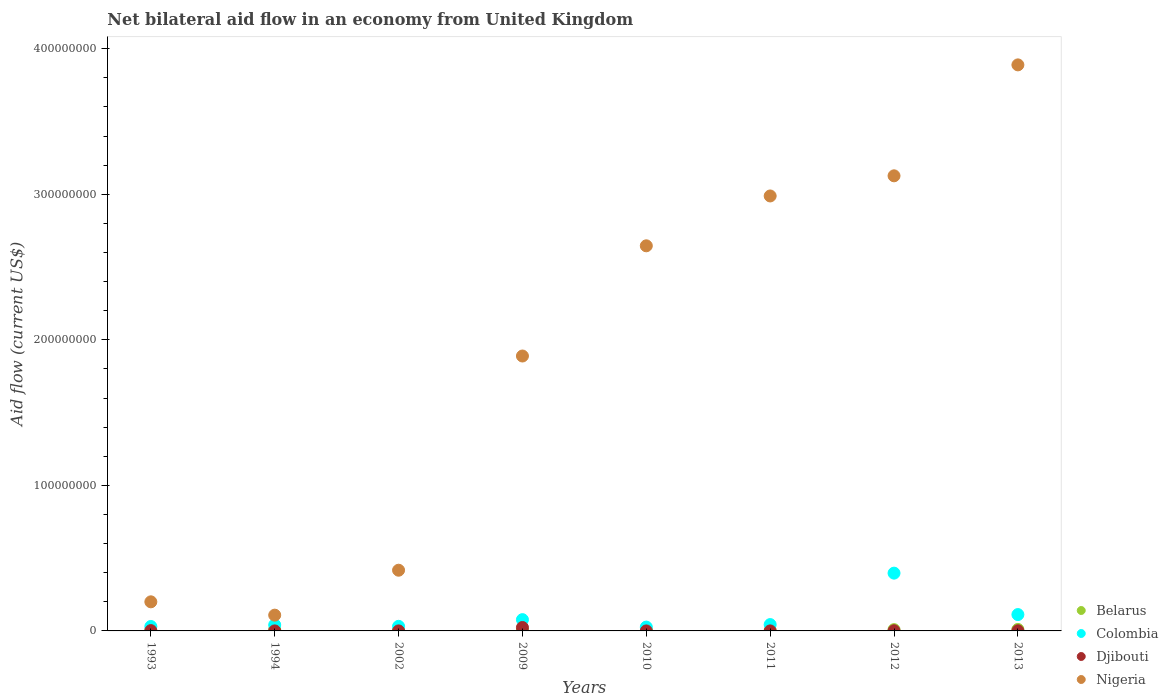How many different coloured dotlines are there?
Your response must be concise. 4. What is the net bilateral aid flow in Belarus in 1993?
Provide a succinct answer. 1.70e+05. Across all years, what is the maximum net bilateral aid flow in Djibouti?
Your response must be concise. 2.35e+06. Across all years, what is the minimum net bilateral aid flow in Nigeria?
Make the answer very short. 1.08e+07. In which year was the net bilateral aid flow in Djibouti maximum?
Offer a very short reply. 2009. In which year was the net bilateral aid flow in Belarus minimum?
Your answer should be compact. 2002. What is the total net bilateral aid flow in Belarus in the graph?
Your answer should be very brief. 4.17e+06. What is the difference between the net bilateral aid flow in Belarus in 1994 and that in 2002?
Your answer should be compact. 8.20e+05. What is the difference between the net bilateral aid flow in Djibouti in 2002 and the net bilateral aid flow in Nigeria in 2013?
Make the answer very short. -3.89e+08. What is the average net bilateral aid flow in Colombia per year?
Provide a succinct answer. 9.50e+06. In the year 1994, what is the difference between the net bilateral aid flow in Djibouti and net bilateral aid flow in Belarus?
Your answer should be very brief. -8.90e+05. What is the ratio of the net bilateral aid flow in Nigeria in 1993 to that in 2013?
Offer a terse response. 0.05. Is the net bilateral aid flow in Colombia in 2010 less than that in 2012?
Offer a terse response. Yes. What is the difference between the highest and the second highest net bilateral aid flow in Djibouti?
Provide a succinct answer. 2.14e+06. What is the difference between the highest and the lowest net bilateral aid flow in Belarus?
Your answer should be very brief. 9.30e+05. Is the sum of the net bilateral aid flow in Nigeria in 1993 and 1994 greater than the maximum net bilateral aid flow in Djibouti across all years?
Provide a succinct answer. Yes. Is it the case that in every year, the sum of the net bilateral aid flow in Colombia and net bilateral aid flow in Nigeria  is greater than the net bilateral aid flow in Djibouti?
Your answer should be very brief. Yes. Does the net bilateral aid flow in Djibouti monotonically increase over the years?
Provide a succinct answer. No. Is the net bilateral aid flow in Djibouti strictly greater than the net bilateral aid flow in Colombia over the years?
Offer a terse response. No. How many years are there in the graph?
Offer a terse response. 8. What is the difference between two consecutive major ticks on the Y-axis?
Give a very brief answer. 1.00e+08. Are the values on the major ticks of Y-axis written in scientific E-notation?
Ensure brevity in your answer.  No. Does the graph contain grids?
Your response must be concise. No. Where does the legend appear in the graph?
Give a very brief answer. Bottom right. How many legend labels are there?
Provide a succinct answer. 4. What is the title of the graph?
Offer a very short reply. Net bilateral aid flow in an economy from United Kingdom. What is the label or title of the X-axis?
Give a very brief answer. Years. What is the label or title of the Y-axis?
Your answer should be compact. Aid flow (current US$). What is the Aid flow (current US$) of Belarus in 1993?
Keep it short and to the point. 1.70e+05. What is the Aid flow (current US$) in Colombia in 1993?
Make the answer very short. 3.04e+06. What is the Aid flow (current US$) of Nigeria in 1993?
Keep it short and to the point. 2.00e+07. What is the Aid flow (current US$) of Belarus in 1994?
Give a very brief answer. 9.10e+05. What is the Aid flow (current US$) in Colombia in 1994?
Ensure brevity in your answer.  4.12e+06. What is the Aid flow (current US$) of Nigeria in 1994?
Offer a terse response. 1.08e+07. What is the Aid flow (current US$) in Belarus in 2002?
Your answer should be compact. 9.00e+04. What is the Aid flow (current US$) in Colombia in 2002?
Your answer should be compact. 3.15e+06. What is the Aid flow (current US$) of Nigeria in 2002?
Keep it short and to the point. 4.17e+07. What is the Aid flow (current US$) in Belarus in 2009?
Your response must be concise. 6.10e+05. What is the Aid flow (current US$) in Colombia in 2009?
Your answer should be compact. 7.75e+06. What is the Aid flow (current US$) of Djibouti in 2009?
Give a very brief answer. 2.35e+06. What is the Aid flow (current US$) of Nigeria in 2009?
Make the answer very short. 1.89e+08. What is the Aid flow (current US$) of Colombia in 2010?
Provide a short and direct response. 2.64e+06. What is the Aid flow (current US$) of Djibouti in 2010?
Ensure brevity in your answer.  10000. What is the Aid flow (current US$) of Nigeria in 2010?
Keep it short and to the point. 2.65e+08. What is the Aid flow (current US$) of Belarus in 2011?
Make the answer very short. 1.20e+05. What is the Aid flow (current US$) of Colombia in 2011?
Ensure brevity in your answer.  4.36e+06. What is the Aid flow (current US$) of Djibouti in 2011?
Make the answer very short. 2.00e+04. What is the Aid flow (current US$) of Nigeria in 2011?
Give a very brief answer. 2.99e+08. What is the Aid flow (current US$) of Belarus in 2012?
Your answer should be compact. 8.80e+05. What is the Aid flow (current US$) of Colombia in 2012?
Ensure brevity in your answer.  3.97e+07. What is the Aid flow (current US$) of Nigeria in 2012?
Give a very brief answer. 3.13e+08. What is the Aid flow (current US$) in Belarus in 2013?
Provide a short and direct response. 1.02e+06. What is the Aid flow (current US$) of Colombia in 2013?
Provide a succinct answer. 1.12e+07. What is the Aid flow (current US$) of Nigeria in 2013?
Make the answer very short. 3.89e+08. Across all years, what is the maximum Aid flow (current US$) of Belarus?
Give a very brief answer. 1.02e+06. Across all years, what is the maximum Aid flow (current US$) of Colombia?
Ensure brevity in your answer.  3.97e+07. Across all years, what is the maximum Aid flow (current US$) of Djibouti?
Keep it short and to the point. 2.35e+06. Across all years, what is the maximum Aid flow (current US$) of Nigeria?
Make the answer very short. 3.89e+08. Across all years, what is the minimum Aid flow (current US$) in Colombia?
Ensure brevity in your answer.  2.64e+06. Across all years, what is the minimum Aid flow (current US$) of Nigeria?
Your answer should be compact. 1.08e+07. What is the total Aid flow (current US$) of Belarus in the graph?
Offer a terse response. 4.17e+06. What is the total Aid flow (current US$) of Colombia in the graph?
Provide a succinct answer. 7.60e+07. What is the total Aid flow (current US$) in Djibouti in the graph?
Provide a succinct answer. 2.84e+06. What is the total Aid flow (current US$) of Nigeria in the graph?
Make the answer very short. 1.53e+09. What is the difference between the Aid flow (current US$) of Belarus in 1993 and that in 1994?
Your answer should be very brief. -7.40e+05. What is the difference between the Aid flow (current US$) in Colombia in 1993 and that in 1994?
Offer a very short reply. -1.08e+06. What is the difference between the Aid flow (current US$) in Djibouti in 1993 and that in 1994?
Your response must be concise. 1.90e+05. What is the difference between the Aid flow (current US$) of Nigeria in 1993 and that in 1994?
Offer a terse response. 9.15e+06. What is the difference between the Aid flow (current US$) of Belarus in 1993 and that in 2002?
Make the answer very short. 8.00e+04. What is the difference between the Aid flow (current US$) of Colombia in 1993 and that in 2002?
Provide a succinct answer. -1.10e+05. What is the difference between the Aid flow (current US$) in Nigeria in 1993 and that in 2002?
Provide a short and direct response. -2.17e+07. What is the difference between the Aid flow (current US$) of Belarus in 1993 and that in 2009?
Ensure brevity in your answer.  -4.40e+05. What is the difference between the Aid flow (current US$) of Colombia in 1993 and that in 2009?
Your answer should be compact. -4.71e+06. What is the difference between the Aid flow (current US$) of Djibouti in 1993 and that in 2009?
Make the answer very short. -2.14e+06. What is the difference between the Aid flow (current US$) of Nigeria in 1993 and that in 2009?
Your answer should be compact. -1.69e+08. What is the difference between the Aid flow (current US$) in Colombia in 1993 and that in 2010?
Provide a short and direct response. 4.00e+05. What is the difference between the Aid flow (current US$) in Djibouti in 1993 and that in 2010?
Keep it short and to the point. 2.00e+05. What is the difference between the Aid flow (current US$) in Nigeria in 1993 and that in 2010?
Provide a short and direct response. -2.45e+08. What is the difference between the Aid flow (current US$) in Belarus in 1993 and that in 2011?
Give a very brief answer. 5.00e+04. What is the difference between the Aid flow (current US$) of Colombia in 1993 and that in 2011?
Your answer should be compact. -1.32e+06. What is the difference between the Aid flow (current US$) in Nigeria in 1993 and that in 2011?
Keep it short and to the point. -2.79e+08. What is the difference between the Aid flow (current US$) in Belarus in 1993 and that in 2012?
Give a very brief answer. -7.10e+05. What is the difference between the Aid flow (current US$) in Colombia in 1993 and that in 2012?
Your answer should be very brief. -3.67e+07. What is the difference between the Aid flow (current US$) in Nigeria in 1993 and that in 2012?
Your answer should be compact. -2.93e+08. What is the difference between the Aid flow (current US$) of Belarus in 1993 and that in 2013?
Your answer should be compact. -8.50e+05. What is the difference between the Aid flow (current US$) of Colombia in 1993 and that in 2013?
Provide a short and direct response. -8.20e+06. What is the difference between the Aid flow (current US$) of Nigeria in 1993 and that in 2013?
Offer a terse response. -3.69e+08. What is the difference between the Aid flow (current US$) of Belarus in 1994 and that in 2002?
Keep it short and to the point. 8.20e+05. What is the difference between the Aid flow (current US$) of Colombia in 1994 and that in 2002?
Provide a short and direct response. 9.70e+05. What is the difference between the Aid flow (current US$) in Nigeria in 1994 and that in 2002?
Keep it short and to the point. -3.09e+07. What is the difference between the Aid flow (current US$) in Belarus in 1994 and that in 2009?
Your answer should be very brief. 3.00e+05. What is the difference between the Aid flow (current US$) in Colombia in 1994 and that in 2009?
Offer a terse response. -3.63e+06. What is the difference between the Aid flow (current US$) of Djibouti in 1994 and that in 2009?
Give a very brief answer. -2.33e+06. What is the difference between the Aid flow (current US$) in Nigeria in 1994 and that in 2009?
Keep it short and to the point. -1.78e+08. What is the difference between the Aid flow (current US$) of Belarus in 1994 and that in 2010?
Your response must be concise. 5.40e+05. What is the difference between the Aid flow (current US$) of Colombia in 1994 and that in 2010?
Your answer should be very brief. 1.48e+06. What is the difference between the Aid flow (current US$) of Djibouti in 1994 and that in 2010?
Your answer should be compact. 10000. What is the difference between the Aid flow (current US$) in Nigeria in 1994 and that in 2010?
Your response must be concise. -2.54e+08. What is the difference between the Aid flow (current US$) in Belarus in 1994 and that in 2011?
Make the answer very short. 7.90e+05. What is the difference between the Aid flow (current US$) of Nigeria in 1994 and that in 2011?
Offer a terse response. -2.88e+08. What is the difference between the Aid flow (current US$) of Colombia in 1994 and that in 2012?
Ensure brevity in your answer.  -3.56e+07. What is the difference between the Aid flow (current US$) of Djibouti in 1994 and that in 2012?
Offer a terse response. -9.00e+04. What is the difference between the Aid flow (current US$) of Nigeria in 1994 and that in 2012?
Offer a terse response. -3.02e+08. What is the difference between the Aid flow (current US$) of Colombia in 1994 and that in 2013?
Provide a succinct answer. -7.12e+06. What is the difference between the Aid flow (current US$) of Nigeria in 1994 and that in 2013?
Provide a succinct answer. -3.78e+08. What is the difference between the Aid flow (current US$) of Belarus in 2002 and that in 2009?
Provide a short and direct response. -5.20e+05. What is the difference between the Aid flow (current US$) in Colombia in 2002 and that in 2009?
Your answer should be compact. -4.60e+06. What is the difference between the Aid flow (current US$) in Djibouti in 2002 and that in 2009?
Ensure brevity in your answer.  -2.33e+06. What is the difference between the Aid flow (current US$) of Nigeria in 2002 and that in 2009?
Provide a succinct answer. -1.47e+08. What is the difference between the Aid flow (current US$) of Belarus in 2002 and that in 2010?
Give a very brief answer. -2.80e+05. What is the difference between the Aid flow (current US$) of Colombia in 2002 and that in 2010?
Make the answer very short. 5.10e+05. What is the difference between the Aid flow (current US$) of Nigeria in 2002 and that in 2010?
Offer a very short reply. -2.23e+08. What is the difference between the Aid flow (current US$) in Belarus in 2002 and that in 2011?
Give a very brief answer. -3.00e+04. What is the difference between the Aid flow (current US$) of Colombia in 2002 and that in 2011?
Your answer should be very brief. -1.21e+06. What is the difference between the Aid flow (current US$) of Djibouti in 2002 and that in 2011?
Your response must be concise. 0. What is the difference between the Aid flow (current US$) in Nigeria in 2002 and that in 2011?
Ensure brevity in your answer.  -2.57e+08. What is the difference between the Aid flow (current US$) in Belarus in 2002 and that in 2012?
Provide a short and direct response. -7.90e+05. What is the difference between the Aid flow (current US$) in Colombia in 2002 and that in 2012?
Your answer should be very brief. -3.66e+07. What is the difference between the Aid flow (current US$) of Nigeria in 2002 and that in 2012?
Your answer should be compact. -2.71e+08. What is the difference between the Aid flow (current US$) in Belarus in 2002 and that in 2013?
Your answer should be compact. -9.30e+05. What is the difference between the Aid flow (current US$) of Colombia in 2002 and that in 2013?
Your answer should be compact. -8.09e+06. What is the difference between the Aid flow (current US$) of Djibouti in 2002 and that in 2013?
Keep it short and to the point. -8.00e+04. What is the difference between the Aid flow (current US$) in Nigeria in 2002 and that in 2013?
Make the answer very short. -3.47e+08. What is the difference between the Aid flow (current US$) in Colombia in 2009 and that in 2010?
Give a very brief answer. 5.11e+06. What is the difference between the Aid flow (current US$) of Djibouti in 2009 and that in 2010?
Make the answer very short. 2.34e+06. What is the difference between the Aid flow (current US$) in Nigeria in 2009 and that in 2010?
Offer a terse response. -7.57e+07. What is the difference between the Aid flow (current US$) in Belarus in 2009 and that in 2011?
Your answer should be compact. 4.90e+05. What is the difference between the Aid flow (current US$) of Colombia in 2009 and that in 2011?
Provide a short and direct response. 3.39e+06. What is the difference between the Aid flow (current US$) in Djibouti in 2009 and that in 2011?
Your response must be concise. 2.33e+06. What is the difference between the Aid flow (current US$) in Nigeria in 2009 and that in 2011?
Provide a short and direct response. -1.10e+08. What is the difference between the Aid flow (current US$) of Belarus in 2009 and that in 2012?
Your answer should be compact. -2.70e+05. What is the difference between the Aid flow (current US$) of Colombia in 2009 and that in 2012?
Offer a very short reply. -3.20e+07. What is the difference between the Aid flow (current US$) of Djibouti in 2009 and that in 2012?
Keep it short and to the point. 2.24e+06. What is the difference between the Aid flow (current US$) in Nigeria in 2009 and that in 2012?
Offer a terse response. -1.24e+08. What is the difference between the Aid flow (current US$) in Belarus in 2009 and that in 2013?
Give a very brief answer. -4.10e+05. What is the difference between the Aid flow (current US$) of Colombia in 2009 and that in 2013?
Keep it short and to the point. -3.49e+06. What is the difference between the Aid flow (current US$) in Djibouti in 2009 and that in 2013?
Keep it short and to the point. 2.25e+06. What is the difference between the Aid flow (current US$) in Nigeria in 2009 and that in 2013?
Offer a terse response. -2.00e+08. What is the difference between the Aid flow (current US$) in Colombia in 2010 and that in 2011?
Your answer should be very brief. -1.72e+06. What is the difference between the Aid flow (current US$) of Nigeria in 2010 and that in 2011?
Your answer should be compact. -3.42e+07. What is the difference between the Aid flow (current US$) in Belarus in 2010 and that in 2012?
Offer a terse response. -5.10e+05. What is the difference between the Aid flow (current US$) of Colombia in 2010 and that in 2012?
Keep it short and to the point. -3.71e+07. What is the difference between the Aid flow (current US$) in Djibouti in 2010 and that in 2012?
Give a very brief answer. -1.00e+05. What is the difference between the Aid flow (current US$) in Nigeria in 2010 and that in 2012?
Your answer should be compact. -4.81e+07. What is the difference between the Aid flow (current US$) of Belarus in 2010 and that in 2013?
Offer a terse response. -6.50e+05. What is the difference between the Aid flow (current US$) of Colombia in 2010 and that in 2013?
Make the answer very short. -8.60e+06. What is the difference between the Aid flow (current US$) of Nigeria in 2010 and that in 2013?
Provide a short and direct response. -1.24e+08. What is the difference between the Aid flow (current US$) in Belarus in 2011 and that in 2012?
Provide a succinct answer. -7.60e+05. What is the difference between the Aid flow (current US$) of Colombia in 2011 and that in 2012?
Ensure brevity in your answer.  -3.53e+07. What is the difference between the Aid flow (current US$) in Nigeria in 2011 and that in 2012?
Your response must be concise. -1.38e+07. What is the difference between the Aid flow (current US$) in Belarus in 2011 and that in 2013?
Keep it short and to the point. -9.00e+05. What is the difference between the Aid flow (current US$) of Colombia in 2011 and that in 2013?
Ensure brevity in your answer.  -6.88e+06. What is the difference between the Aid flow (current US$) of Nigeria in 2011 and that in 2013?
Your response must be concise. -9.01e+07. What is the difference between the Aid flow (current US$) of Belarus in 2012 and that in 2013?
Provide a succinct answer. -1.40e+05. What is the difference between the Aid flow (current US$) of Colombia in 2012 and that in 2013?
Offer a terse response. 2.85e+07. What is the difference between the Aid flow (current US$) of Djibouti in 2012 and that in 2013?
Your answer should be compact. 10000. What is the difference between the Aid flow (current US$) in Nigeria in 2012 and that in 2013?
Ensure brevity in your answer.  -7.62e+07. What is the difference between the Aid flow (current US$) in Belarus in 1993 and the Aid flow (current US$) in Colombia in 1994?
Your answer should be very brief. -3.95e+06. What is the difference between the Aid flow (current US$) in Belarus in 1993 and the Aid flow (current US$) in Nigeria in 1994?
Ensure brevity in your answer.  -1.07e+07. What is the difference between the Aid flow (current US$) of Colombia in 1993 and the Aid flow (current US$) of Djibouti in 1994?
Provide a succinct answer. 3.02e+06. What is the difference between the Aid flow (current US$) of Colombia in 1993 and the Aid flow (current US$) of Nigeria in 1994?
Make the answer very short. -7.80e+06. What is the difference between the Aid flow (current US$) in Djibouti in 1993 and the Aid flow (current US$) in Nigeria in 1994?
Keep it short and to the point. -1.06e+07. What is the difference between the Aid flow (current US$) in Belarus in 1993 and the Aid flow (current US$) in Colombia in 2002?
Your answer should be compact. -2.98e+06. What is the difference between the Aid flow (current US$) in Belarus in 1993 and the Aid flow (current US$) in Djibouti in 2002?
Make the answer very short. 1.50e+05. What is the difference between the Aid flow (current US$) in Belarus in 1993 and the Aid flow (current US$) in Nigeria in 2002?
Offer a terse response. -4.15e+07. What is the difference between the Aid flow (current US$) of Colombia in 1993 and the Aid flow (current US$) of Djibouti in 2002?
Offer a very short reply. 3.02e+06. What is the difference between the Aid flow (current US$) in Colombia in 1993 and the Aid flow (current US$) in Nigeria in 2002?
Your response must be concise. -3.87e+07. What is the difference between the Aid flow (current US$) in Djibouti in 1993 and the Aid flow (current US$) in Nigeria in 2002?
Keep it short and to the point. -4.15e+07. What is the difference between the Aid flow (current US$) in Belarus in 1993 and the Aid flow (current US$) in Colombia in 2009?
Offer a terse response. -7.58e+06. What is the difference between the Aid flow (current US$) in Belarus in 1993 and the Aid flow (current US$) in Djibouti in 2009?
Your answer should be compact. -2.18e+06. What is the difference between the Aid flow (current US$) of Belarus in 1993 and the Aid flow (current US$) of Nigeria in 2009?
Your answer should be compact. -1.89e+08. What is the difference between the Aid flow (current US$) of Colombia in 1993 and the Aid flow (current US$) of Djibouti in 2009?
Make the answer very short. 6.90e+05. What is the difference between the Aid flow (current US$) of Colombia in 1993 and the Aid flow (current US$) of Nigeria in 2009?
Your answer should be compact. -1.86e+08. What is the difference between the Aid flow (current US$) in Djibouti in 1993 and the Aid flow (current US$) in Nigeria in 2009?
Provide a succinct answer. -1.89e+08. What is the difference between the Aid flow (current US$) in Belarus in 1993 and the Aid flow (current US$) in Colombia in 2010?
Ensure brevity in your answer.  -2.47e+06. What is the difference between the Aid flow (current US$) of Belarus in 1993 and the Aid flow (current US$) of Djibouti in 2010?
Keep it short and to the point. 1.60e+05. What is the difference between the Aid flow (current US$) in Belarus in 1993 and the Aid flow (current US$) in Nigeria in 2010?
Your response must be concise. -2.64e+08. What is the difference between the Aid flow (current US$) in Colombia in 1993 and the Aid flow (current US$) in Djibouti in 2010?
Your response must be concise. 3.03e+06. What is the difference between the Aid flow (current US$) in Colombia in 1993 and the Aid flow (current US$) in Nigeria in 2010?
Give a very brief answer. -2.62e+08. What is the difference between the Aid flow (current US$) of Djibouti in 1993 and the Aid flow (current US$) of Nigeria in 2010?
Provide a succinct answer. -2.64e+08. What is the difference between the Aid flow (current US$) of Belarus in 1993 and the Aid flow (current US$) of Colombia in 2011?
Ensure brevity in your answer.  -4.19e+06. What is the difference between the Aid flow (current US$) in Belarus in 1993 and the Aid flow (current US$) in Nigeria in 2011?
Your answer should be very brief. -2.99e+08. What is the difference between the Aid flow (current US$) in Colombia in 1993 and the Aid flow (current US$) in Djibouti in 2011?
Provide a succinct answer. 3.02e+06. What is the difference between the Aid flow (current US$) in Colombia in 1993 and the Aid flow (current US$) in Nigeria in 2011?
Your answer should be very brief. -2.96e+08. What is the difference between the Aid flow (current US$) of Djibouti in 1993 and the Aid flow (current US$) of Nigeria in 2011?
Your answer should be very brief. -2.99e+08. What is the difference between the Aid flow (current US$) of Belarus in 1993 and the Aid flow (current US$) of Colombia in 2012?
Make the answer very short. -3.95e+07. What is the difference between the Aid flow (current US$) of Belarus in 1993 and the Aid flow (current US$) of Nigeria in 2012?
Provide a succinct answer. -3.13e+08. What is the difference between the Aid flow (current US$) of Colombia in 1993 and the Aid flow (current US$) of Djibouti in 2012?
Make the answer very short. 2.93e+06. What is the difference between the Aid flow (current US$) in Colombia in 1993 and the Aid flow (current US$) in Nigeria in 2012?
Offer a terse response. -3.10e+08. What is the difference between the Aid flow (current US$) in Djibouti in 1993 and the Aid flow (current US$) in Nigeria in 2012?
Give a very brief answer. -3.12e+08. What is the difference between the Aid flow (current US$) in Belarus in 1993 and the Aid flow (current US$) in Colombia in 2013?
Offer a very short reply. -1.11e+07. What is the difference between the Aid flow (current US$) of Belarus in 1993 and the Aid flow (current US$) of Nigeria in 2013?
Your answer should be compact. -3.89e+08. What is the difference between the Aid flow (current US$) in Colombia in 1993 and the Aid flow (current US$) in Djibouti in 2013?
Keep it short and to the point. 2.94e+06. What is the difference between the Aid flow (current US$) in Colombia in 1993 and the Aid flow (current US$) in Nigeria in 2013?
Make the answer very short. -3.86e+08. What is the difference between the Aid flow (current US$) in Djibouti in 1993 and the Aid flow (current US$) in Nigeria in 2013?
Keep it short and to the point. -3.89e+08. What is the difference between the Aid flow (current US$) in Belarus in 1994 and the Aid flow (current US$) in Colombia in 2002?
Keep it short and to the point. -2.24e+06. What is the difference between the Aid flow (current US$) of Belarus in 1994 and the Aid flow (current US$) of Djibouti in 2002?
Provide a short and direct response. 8.90e+05. What is the difference between the Aid flow (current US$) in Belarus in 1994 and the Aid flow (current US$) in Nigeria in 2002?
Keep it short and to the point. -4.08e+07. What is the difference between the Aid flow (current US$) of Colombia in 1994 and the Aid flow (current US$) of Djibouti in 2002?
Your response must be concise. 4.10e+06. What is the difference between the Aid flow (current US$) in Colombia in 1994 and the Aid flow (current US$) in Nigeria in 2002?
Make the answer very short. -3.76e+07. What is the difference between the Aid flow (current US$) in Djibouti in 1994 and the Aid flow (current US$) in Nigeria in 2002?
Provide a succinct answer. -4.17e+07. What is the difference between the Aid flow (current US$) in Belarus in 1994 and the Aid flow (current US$) in Colombia in 2009?
Your answer should be compact. -6.84e+06. What is the difference between the Aid flow (current US$) in Belarus in 1994 and the Aid flow (current US$) in Djibouti in 2009?
Your answer should be compact. -1.44e+06. What is the difference between the Aid flow (current US$) in Belarus in 1994 and the Aid flow (current US$) in Nigeria in 2009?
Offer a very short reply. -1.88e+08. What is the difference between the Aid flow (current US$) in Colombia in 1994 and the Aid flow (current US$) in Djibouti in 2009?
Offer a terse response. 1.77e+06. What is the difference between the Aid flow (current US$) in Colombia in 1994 and the Aid flow (current US$) in Nigeria in 2009?
Offer a very short reply. -1.85e+08. What is the difference between the Aid flow (current US$) in Djibouti in 1994 and the Aid flow (current US$) in Nigeria in 2009?
Provide a succinct answer. -1.89e+08. What is the difference between the Aid flow (current US$) in Belarus in 1994 and the Aid flow (current US$) in Colombia in 2010?
Your response must be concise. -1.73e+06. What is the difference between the Aid flow (current US$) in Belarus in 1994 and the Aid flow (current US$) in Djibouti in 2010?
Your response must be concise. 9.00e+05. What is the difference between the Aid flow (current US$) of Belarus in 1994 and the Aid flow (current US$) of Nigeria in 2010?
Provide a succinct answer. -2.64e+08. What is the difference between the Aid flow (current US$) in Colombia in 1994 and the Aid flow (current US$) in Djibouti in 2010?
Your response must be concise. 4.11e+06. What is the difference between the Aid flow (current US$) of Colombia in 1994 and the Aid flow (current US$) of Nigeria in 2010?
Ensure brevity in your answer.  -2.60e+08. What is the difference between the Aid flow (current US$) of Djibouti in 1994 and the Aid flow (current US$) of Nigeria in 2010?
Provide a succinct answer. -2.65e+08. What is the difference between the Aid flow (current US$) of Belarus in 1994 and the Aid flow (current US$) of Colombia in 2011?
Your answer should be very brief. -3.45e+06. What is the difference between the Aid flow (current US$) in Belarus in 1994 and the Aid flow (current US$) in Djibouti in 2011?
Your answer should be very brief. 8.90e+05. What is the difference between the Aid flow (current US$) in Belarus in 1994 and the Aid flow (current US$) in Nigeria in 2011?
Offer a terse response. -2.98e+08. What is the difference between the Aid flow (current US$) of Colombia in 1994 and the Aid flow (current US$) of Djibouti in 2011?
Your answer should be very brief. 4.10e+06. What is the difference between the Aid flow (current US$) of Colombia in 1994 and the Aid flow (current US$) of Nigeria in 2011?
Your answer should be compact. -2.95e+08. What is the difference between the Aid flow (current US$) of Djibouti in 1994 and the Aid flow (current US$) of Nigeria in 2011?
Your response must be concise. -2.99e+08. What is the difference between the Aid flow (current US$) of Belarus in 1994 and the Aid flow (current US$) of Colombia in 2012?
Provide a succinct answer. -3.88e+07. What is the difference between the Aid flow (current US$) of Belarus in 1994 and the Aid flow (current US$) of Nigeria in 2012?
Make the answer very short. -3.12e+08. What is the difference between the Aid flow (current US$) in Colombia in 1994 and the Aid flow (current US$) in Djibouti in 2012?
Offer a very short reply. 4.01e+06. What is the difference between the Aid flow (current US$) in Colombia in 1994 and the Aid flow (current US$) in Nigeria in 2012?
Keep it short and to the point. -3.09e+08. What is the difference between the Aid flow (current US$) in Djibouti in 1994 and the Aid flow (current US$) in Nigeria in 2012?
Make the answer very short. -3.13e+08. What is the difference between the Aid flow (current US$) in Belarus in 1994 and the Aid flow (current US$) in Colombia in 2013?
Give a very brief answer. -1.03e+07. What is the difference between the Aid flow (current US$) in Belarus in 1994 and the Aid flow (current US$) in Djibouti in 2013?
Keep it short and to the point. 8.10e+05. What is the difference between the Aid flow (current US$) in Belarus in 1994 and the Aid flow (current US$) in Nigeria in 2013?
Your answer should be very brief. -3.88e+08. What is the difference between the Aid flow (current US$) in Colombia in 1994 and the Aid flow (current US$) in Djibouti in 2013?
Offer a terse response. 4.02e+06. What is the difference between the Aid flow (current US$) in Colombia in 1994 and the Aid flow (current US$) in Nigeria in 2013?
Your response must be concise. -3.85e+08. What is the difference between the Aid flow (current US$) in Djibouti in 1994 and the Aid flow (current US$) in Nigeria in 2013?
Offer a very short reply. -3.89e+08. What is the difference between the Aid flow (current US$) of Belarus in 2002 and the Aid flow (current US$) of Colombia in 2009?
Ensure brevity in your answer.  -7.66e+06. What is the difference between the Aid flow (current US$) in Belarus in 2002 and the Aid flow (current US$) in Djibouti in 2009?
Offer a terse response. -2.26e+06. What is the difference between the Aid flow (current US$) in Belarus in 2002 and the Aid flow (current US$) in Nigeria in 2009?
Your response must be concise. -1.89e+08. What is the difference between the Aid flow (current US$) of Colombia in 2002 and the Aid flow (current US$) of Nigeria in 2009?
Provide a short and direct response. -1.86e+08. What is the difference between the Aid flow (current US$) in Djibouti in 2002 and the Aid flow (current US$) in Nigeria in 2009?
Your answer should be compact. -1.89e+08. What is the difference between the Aid flow (current US$) in Belarus in 2002 and the Aid flow (current US$) in Colombia in 2010?
Give a very brief answer. -2.55e+06. What is the difference between the Aid flow (current US$) in Belarus in 2002 and the Aid flow (current US$) in Djibouti in 2010?
Provide a succinct answer. 8.00e+04. What is the difference between the Aid flow (current US$) in Belarus in 2002 and the Aid flow (current US$) in Nigeria in 2010?
Your answer should be very brief. -2.65e+08. What is the difference between the Aid flow (current US$) in Colombia in 2002 and the Aid flow (current US$) in Djibouti in 2010?
Your response must be concise. 3.14e+06. What is the difference between the Aid flow (current US$) of Colombia in 2002 and the Aid flow (current US$) of Nigeria in 2010?
Offer a terse response. -2.61e+08. What is the difference between the Aid flow (current US$) in Djibouti in 2002 and the Aid flow (current US$) in Nigeria in 2010?
Your answer should be compact. -2.65e+08. What is the difference between the Aid flow (current US$) in Belarus in 2002 and the Aid flow (current US$) in Colombia in 2011?
Make the answer very short. -4.27e+06. What is the difference between the Aid flow (current US$) of Belarus in 2002 and the Aid flow (current US$) of Djibouti in 2011?
Provide a short and direct response. 7.00e+04. What is the difference between the Aid flow (current US$) of Belarus in 2002 and the Aid flow (current US$) of Nigeria in 2011?
Your answer should be compact. -2.99e+08. What is the difference between the Aid flow (current US$) in Colombia in 2002 and the Aid flow (current US$) in Djibouti in 2011?
Offer a terse response. 3.13e+06. What is the difference between the Aid flow (current US$) in Colombia in 2002 and the Aid flow (current US$) in Nigeria in 2011?
Offer a very short reply. -2.96e+08. What is the difference between the Aid flow (current US$) of Djibouti in 2002 and the Aid flow (current US$) of Nigeria in 2011?
Your response must be concise. -2.99e+08. What is the difference between the Aid flow (current US$) in Belarus in 2002 and the Aid flow (current US$) in Colombia in 2012?
Provide a short and direct response. -3.96e+07. What is the difference between the Aid flow (current US$) of Belarus in 2002 and the Aid flow (current US$) of Djibouti in 2012?
Offer a very short reply. -2.00e+04. What is the difference between the Aid flow (current US$) of Belarus in 2002 and the Aid flow (current US$) of Nigeria in 2012?
Provide a succinct answer. -3.13e+08. What is the difference between the Aid flow (current US$) of Colombia in 2002 and the Aid flow (current US$) of Djibouti in 2012?
Ensure brevity in your answer.  3.04e+06. What is the difference between the Aid flow (current US$) of Colombia in 2002 and the Aid flow (current US$) of Nigeria in 2012?
Give a very brief answer. -3.10e+08. What is the difference between the Aid flow (current US$) of Djibouti in 2002 and the Aid flow (current US$) of Nigeria in 2012?
Provide a succinct answer. -3.13e+08. What is the difference between the Aid flow (current US$) of Belarus in 2002 and the Aid flow (current US$) of Colombia in 2013?
Your response must be concise. -1.12e+07. What is the difference between the Aid flow (current US$) in Belarus in 2002 and the Aid flow (current US$) in Djibouti in 2013?
Your response must be concise. -10000. What is the difference between the Aid flow (current US$) in Belarus in 2002 and the Aid flow (current US$) in Nigeria in 2013?
Your answer should be compact. -3.89e+08. What is the difference between the Aid flow (current US$) in Colombia in 2002 and the Aid flow (current US$) in Djibouti in 2013?
Make the answer very short. 3.05e+06. What is the difference between the Aid flow (current US$) of Colombia in 2002 and the Aid flow (current US$) of Nigeria in 2013?
Your answer should be compact. -3.86e+08. What is the difference between the Aid flow (current US$) of Djibouti in 2002 and the Aid flow (current US$) of Nigeria in 2013?
Ensure brevity in your answer.  -3.89e+08. What is the difference between the Aid flow (current US$) in Belarus in 2009 and the Aid flow (current US$) in Colombia in 2010?
Your answer should be very brief. -2.03e+06. What is the difference between the Aid flow (current US$) in Belarus in 2009 and the Aid flow (current US$) in Djibouti in 2010?
Give a very brief answer. 6.00e+05. What is the difference between the Aid flow (current US$) in Belarus in 2009 and the Aid flow (current US$) in Nigeria in 2010?
Provide a succinct answer. -2.64e+08. What is the difference between the Aid flow (current US$) in Colombia in 2009 and the Aid flow (current US$) in Djibouti in 2010?
Your answer should be very brief. 7.74e+06. What is the difference between the Aid flow (current US$) in Colombia in 2009 and the Aid flow (current US$) in Nigeria in 2010?
Your response must be concise. -2.57e+08. What is the difference between the Aid flow (current US$) of Djibouti in 2009 and the Aid flow (current US$) of Nigeria in 2010?
Give a very brief answer. -2.62e+08. What is the difference between the Aid flow (current US$) of Belarus in 2009 and the Aid flow (current US$) of Colombia in 2011?
Keep it short and to the point. -3.75e+06. What is the difference between the Aid flow (current US$) of Belarus in 2009 and the Aid flow (current US$) of Djibouti in 2011?
Make the answer very short. 5.90e+05. What is the difference between the Aid flow (current US$) of Belarus in 2009 and the Aid flow (current US$) of Nigeria in 2011?
Provide a short and direct response. -2.98e+08. What is the difference between the Aid flow (current US$) in Colombia in 2009 and the Aid flow (current US$) in Djibouti in 2011?
Make the answer very short. 7.73e+06. What is the difference between the Aid flow (current US$) in Colombia in 2009 and the Aid flow (current US$) in Nigeria in 2011?
Your answer should be very brief. -2.91e+08. What is the difference between the Aid flow (current US$) in Djibouti in 2009 and the Aid flow (current US$) in Nigeria in 2011?
Give a very brief answer. -2.97e+08. What is the difference between the Aid flow (current US$) of Belarus in 2009 and the Aid flow (current US$) of Colombia in 2012?
Make the answer very short. -3.91e+07. What is the difference between the Aid flow (current US$) in Belarus in 2009 and the Aid flow (current US$) in Nigeria in 2012?
Ensure brevity in your answer.  -3.12e+08. What is the difference between the Aid flow (current US$) of Colombia in 2009 and the Aid flow (current US$) of Djibouti in 2012?
Provide a short and direct response. 7.64e+06. What is the difference between the Aid flow (current US$) in Colombia in 2009 and the Aid flow (current US$) in Nigeria in 2012?
Make the answer very short. -3.05e+08. What is the difference between the Aid flow (current US$) of Djibouti in 2009 and the Aid flow (current US$) of Nigeria in 2012?
Provide a succinct answer. -3.10e+08. What is the difference between the Aid flow (current US$) of Belarus in 2009 and the Aid flow (current US$) of Colombia in 2013?
Offer a terse response. -1.06e+07. What is the difference between the Aid flow (current US$) in Belarus in 2009 and the Aid flow (current US$) in Djibouti in 2013?
Provide a succinct answer. 5.10e+05. What is the difference between the Aid flow (current US$) of Belarus in 2009 and the Aid flow (current US$) of Nigeria in 2013?
Provide a succinct answer. -3.88e+08. What is the difference between the Aid flow (current US$) of Colombia in 2009 and the Aid flow (current US$) of Djibouti in 2013?
Provide a short and direct response. 7.65e+06. What is the difference between the Aid flow (current US$) in Colombia in 2009 and the Aid flow (current US$) in Nigeria in 2013?
Your answer should be compact. -3.81e+08. What is the difference between the Aid flow (current US$) in Djibouti in 2009 and the Aid flow (current US$) in Nigeria in 2013?
Offer a terse response. -3.87e+08. What is the difference between the Aid flow (current US$) of Belarus in 2010 and the Aid flow (current US$) of Colombia in 2011?
Ensure brevity in your answer.  -3.99e+06. What is the difference between the Aid flow (current US$) in Belarus in 2010 and the Aid flow (current US$) in Nigeria in 2011?
Make the answer very short. -2.98e+08. What is the difference between the Aid flow (current US$) in Colombia in 2010 and the Aid flow (current US$) in Djibouti in 2011?
Offer a terse response. 2.62e+06. What is the difference between the Aid flow (current US$) of Colombia in 2010 and the Aid flow (current US$) of Nigeria in 2011?
Keep it short and to the point. -2.96e+08. What is the difference between the Aid flow (current US$) in Djibouti in 2010 and the Aid flow (current US$) in Nigeria in 2011?
Your answer should be very brief. -2.99e+08. What is the difference between the Aid flow (current US$) of Belarus in 2010 and the Aid flow (current US$) of Colombia in 2012?
Your answer should be very brief. -3.93e+07. What is the difference between the Aid flow (current US$) in Belarus in 2010 and the Aid flow (current US$) in Nigeria in 2012?
Your answer should be very brief. -3.12e+08. What is the difference between the Aid flow (current US$) of Colombia in 2010 and the Aid flow (current US$) of Djibouti in 2012?
Make the answer very short. 2.53e+06. What is the difference between the Aid flow (current US$) in Colombia in 2010 and the Aid flow (current US$) in Nigeria in 2012?
Keep it short and to the point. -3.10e+08. What is the difference between the Aid flow (current US$) of Djibouti in 2010 and the Aid flow (current US$) of Nigeria in 2012?
Make the answer very short. -3.13e+08. What is the difference between the Aid flow (current US$) in Belarus in 2010 and the Aid flow (current US$) in Colombia in 2013?
Your response must be concise. -1.09e+07. What is the difference between the Aid flow (current US$) in Belarus in 2010 and the Aid flow (current US$) in Djibouti in 2013?
Provide a succinct answer. 2.70e+05. What is the difference between the Aid flow (current US$) of Belarus in 2010 and the Aid flow (current US$) of Nigeria in 2013?
Your response must be concise. -3.89e+08. What is the difference between the Aid flow (current US$) of Colombia in 2010 and the Aid flow (current US$) of Djibouti in 2013?
Keep it short and to the point. 2.54e+06. What is the difference between the Aid flow (current US$) of Colombia in 2010 and the Aid flow (current US$) of Nigeria in 2013?
Your response must be concise. -3.86e+08. What is the difference between the Aid flow (current US$) of Djibouti in 2010 and the Aid flow (current US$) of Nigeria in 2013?
Ensure brevity in your answer.  -3.89e+08. What is the difference between the Aid flow (current US$) of Belarus in 2011 and the Aid flow (current US$) of Colombia in 2012?
Offer a terse response. -3.96e+07. What is the difference between the Aid flow (current US$) in Belarus in 2011 and the Aid flow (current US$) in Djibouti in 2012?
Make the answer very short. 10000. What is the difference between the Aid flow (current US$) in Belarus in 2011 and the Aid flow (current US$) in Nigeria in 2012?
Offer a terse response. -3.13e+08. What is the difference between the Aid flow (current US$) in Colombia in 2011 and the Aid flow (current US$) in Djibouti in 2012?
Offer a very short reply. 4.25e+06. What is the difference between the Aid flow (current US$) of Colombia in 2011 and the Aid flow (current US$) of Nigeria in 2012?
Give a very brief answer. -3.08e+08. What is the difference between the Aid flow (current US$) of Djibouti in 2011 and the Aid flow (current US$) of Nigeria in 2012?
Give a very brief answer. -3.13e+08. What is the difference between the Aid flow (current US$) of Belarus in 2011 and the Aid flow (current US$) of Colombia in 2013?
Make the answer very short. -1.11e+07. What is the difference between the Aid flow (current US$) in Belarus in 2011 and the Aid flow (current US$) in Nigeria in 2013?
Offer a very short reply. -3.89e+08. What is the difference between the Aid flow (current US$) in Colombia in 2011 and the Aid flow (current US$) in Djibouti in 2013?
Provide a short and direct response. 4.26e+06. What is the difference between the Aid flow (current US$) in Colombia in 2011 and the Aid flow (current US$) in Nigeria in 2013?
Give a very brief answer. -3.85e+08. What is the difference between the Aid flow (current US$) of Djibouti in 2011 and the Aid flow (current US$) of Nigeria in 2013?
Your response must be concise. -3.89e+08. What is the difference between the Aid flow (current US$) of Belarus in 2012 and the Aid flow (current US$) of Colombia in 2013?
Offer a terse response. -1.04e+07. What is the difference between the Aid flow (current US$) in Belarus in 2012 and the Aid flow (current US$) in Djibouti in 2013?
Give a very brief answer. 7.80e+05. What is the difference between the Aid flow (current US$) of Belarus in 2012 and the Aid flow (current US$) of Nigeria in 2013?
Provide a short and direct response. -3.88e+08. What is the difference between the Aid flow (current US$) in Colombia in 2012 and the Aid flow (current US$) in Djibouti in 2013?
Provide a short and direct response. 3.96e+07. What is the difference between the Aid flow (current US$) of Colombia in 2012 and the Aid flow (current US$) of Nigeria in 2013?
Give a very brief answer. -3.49e+08. What is the difference between the Aid flow (current US$) of Djibouti in 2012 and the Aid flow (current US$) of Nigeria in 2013?
Provide a succinct answer. -3.89e+08. What is the average Aid flow (current US$) of Belarus per year?
Your answer should be very brief. 5.21e+05. What is the average Aid flow (current US$) of Colombia per year?
Your response must be concise. 9.50e+06. What is the average Aid flow (current US$) in Djibouti per year?
Your answer should be compact. 3.55e+05. What is the average Aid flow (current US$) in Nigeria per year?
Your response must be concise. 1.91e+08. In the year 1993, what is the difference between the Aid flow (current US$) of Belarus and Aid flow (current US$) of Colombia?
Ensure brevity in your answer.  -2.87e+06. In the year 1993, what is the difference between the Aid flow (current US$) of Belarus and Aid flow (current US$) of Nigeria?
Keep it short and to the point. -1.98e+07. In the year 1993, what is the difference between the Aid flow (current US$) in Colombia and Aid flow (current US$) in Djibouti?
Offer a terse response. 2.83e+06. In the year 1993, what is the difference between the Aid flow (current US$) of Colombia and Aid flow (current US$) of Nigeria?
Keep it short and to the point. -1.70e+07. In the year 1993, what is the difference between the Aid flow (current US$) of Djibouti and Aid flow (current US$) of Nigeria?
Give a very brief answer. -1.98e+07. In the year 1994, what is the difference between the Aid flow (current US$) in Belarus and Aid flow (current US$) in Colombia?
Your answer should be very brief. -3.21e+06. In the year 1994, what is the difference between the Aid flow (current US$) in Belarus and Aid flow (current US$) in Djibouti?
Your response must be concise. 8.90e+05. In the year 1994, what is the difference between the Aid flow (current US$) of Belarus and Aid flow (current US$) of Nigeria?
Your answer should be compact. -9.93e+06. In the year 1994, what is the difference between the Aid flow (current US$) of Colombia and Aid flow (current US$) of Djibouti?
Provide a succinct answer. 4.10e+06. In the year 1994, what is the difference between the Aid flow (current US$) in Colombia and Aid flow (current US$) in Nigeria?
Make the answer very short. -6.72e+06. In the year 1994, what is the difference between the Aid flow (current US$) in Djibouti and Aid flow (current US$) in Nigeria?
Provide a succinct answer. -1.08e+07. In the year 2002, what is the difference between the Aid flow (current US$) of Belarus and Aid flow (current US$) of Colombia?
Ensure brevity in your answer.  -3.06e+06. In the year 2002, what is the difference between the Aid flow (current US$) in Belarus and Aid flow (current US$) in Djibouti?
Give a very brief answer. 7.00e+04. In the year 2002, what is the difference between the Aid flow (current US$) in Belarus and Aid flow (current US$) in Nigeria?
Give a very brief answer. -4.16e+07. In the year 2002, what is the difference between the Aid flow (current US$) of Colombia and Aid flow (current US$) of Djibouti?
Provide a short and direct response. 3.13e+06. In the year 2002, what is the difference between the Aid flow (current US$) in Colombia and Aid flow (current US$) in Nigeria?
Your answer should be compact. -3.86e+07. In the year 2002, what is the difference between the Aid flow (current US$) of Djibouti and Aid flow (current US$) of Nigeria?
Your answer should be very brief. -4.17e+07. In the year 2009, what is the difference between the Aid flow (current US$) in Belarus and Aid flow (current US$) in Colombia?
Keep it short and to the point. -7.14e+06. In the year 2009, what is the difference between the Aid flow (current US$) of Belarus and Aid flow (current US$) of Djibouti?
Offer a very short reply. -1.74e+06. In the year 2009, what is the difference between the Aid flow (current US$) in Belarus and Aid flow (current US$) in Nigeria?
Your answer should be compact. -1.88e+08. In the year 2009, what is the difference between the Aid flow (current US$) in Colombia and Aid flow (current US$) in Djibouti?
Your response must be concise. 5.40e+06. In the year 2009, what is the difference between the Aid flow (current US$) of Colombia and Aid flow (current US$) of Nigeria?
Make the answer very short. -1.81e+08. In the year 2009, what is the difference between the Aid flow (current US$) of Djibouti and Aid flow (current US$) of Nigeria?
Give a very brief answer. -1.87e+08. In the year 2010, what is the difference between the Aid flow (current US$) in Belarus and Aid flow (current US$) in Colombia?
Ensure brevity in your answer.  -2.27e+06. In the year 2010, what is the difference between the Aid flow (current US$) of Belarus and Aid flow (current US$) of Nigeria?
Keep it short and to the point. -2.64e+08. In the year 2010, what is the difference between the Aid flow (current US$) in Colombia and Aid flow (current US$) in Djibouti?
Ensure brevity in your answer.  2.63e+06. In the year 2010, what is the difference between the Aid flow (current US$) of Colombia and Aid flow (current US$) of Nigeria?
Your response must be concise. -2.62e+08. In the year 2010, what is the difference between the Aid flow (current US$) in Djibouti and Aid flow (current US$) in Nigeria?
Provide a succinct answer. -2.65e+08. In the year 2011, what is the difference between the Aid flow (current US$) in Belarus and Aid flow (current US$) in Colombia?
Offer a very short reply. -4.24e+06. In the year 2011, what is the difference between the Aid flow (current US$) in Belarus and Aid flow (current US$) in Nigeria?
Keep it short and to the point. -2.99e+08. In the year 2011, what is the difference between the Aid flow (current US$) of Colombia and Aid flow (current US$) of Djibouti?
Offer a very short reply. 4.34e+06. In the year 2011, what is the difference between the Aid flow (current US$) of Colombia and Aid flow (current US$) of Nigeria?
Offer a very short reply. -2.94e+08. In the year 2011, what is the difference between the Aid flow (current US$) in Djibouti and Aid flow (current US$) in Nigeria?
Give a very brief answer. -2.99e+08. In the year 2012, what is the difference between the Aid flow (current US$) of Belarus and Aid flow (current US$) of Colombia?
Your response must be concise. -3.88e+07. In the year 2012, what is the difference between the Aid flow (current US$) of Belarus and Aid flow (current US$) of Djibouti?
Provide a short and direct response. 7.70e+05. In the year 2012, what is the difference between the Aid flow (current US$) of Belarus and Aid flow (current US$) of Nigeria?
Ensure brevity in your answer.  -3.12e+08. In the year 2012, what is the difference between the Aid flow (current US$) in Colombia and Aid flow (current US$) in Djibouti?
Give a very brief answer. 3.96e+07. In the year 2012, what is the difference between the Aid flow (current US$) in Colombia and Aid flow (current US$) in Nigeria?
Provide a short and direct response. -2.73e+08. In the year 2012, what is the difference between the Aid flow (current US$) of Djibouti and Aid flow (current US$) of Nigeria?
Provide a short and direct response. -3.13e+08. In the year 2013, what is the difference between the Aid flow (current US$) in Belarus and Aid flow (current US$) in Colombia?
Offer a very short reply. -1.02e+07. In the year 2013, what is the difference between the Aid flow (current US$) in Belarus and Aid flow (current US$) in Djibouti?
Ensure brevity in your answer.  9.20e+05. In the year 2013, what is the difference between the Aid flow (current US$) of Belarus and Aid flow (current US$) of Nigeria?
Offer a terse response. -3.88e+08. In the year 2013, what is the difference between the Aid flow (current US$) of Colombia and Aid flow (current US$) of Djibouti?
Give a very brief answer. 1.11e+07. In the year 2013, what is the difference between the Aid flow (current US$) of Colombia and Aid flow (current US$) of Nigeria?
Offer a very short reply. -3.78e+08. In the year 2013, what is the difference between the Aid flow (current US$) in Djibouti and Aid flow (current US$) in Nigeria?
Provide a succinct answer. -3.89e+08. What is the ratio of the Aid flow (current US$) in Belarus in 1993 to that in 1994?
Provide a short and direct response. 0.19. What is the ratio of the Aid flow (current US$) of Colombia in 1993 to that in 1994?
Give a very brief answer. 0.74. What is the ratio of the Aid flow (current US$) in Djibouti in 1993 to that in 1994?
Keep it short and to the point. 10.5. What is the ratio of the Aid flow (current US$) in Nigeria in 1993 to that in 1994?
Ensure brevity in your answer.  1.84. What is the ratio of the Aid flow (current US$) of Belarus in 1993 to that in 2002?
Offer a very short reply. 1.89. What is the ratio of the Aid flow (current US$) of Colombia in 1993 to that in 2002?
Offer a very short reply. 0.97. What is the ratio of the Aid flow (current US$) in Djibouti in 1993 to that in 2002?
Make the answer very short. 10.5. What is the ratio of the Aid flow (current US$) in Nigeria in 1993 to that in 2002?
Give a very brief answer. 0.48. What is the ratio of the Aid flow (current US$) in Belarus in 1993 to that in 2009?
Your answer should be compact. 0.28. What is the ratio of the Aid flow (current US$) in Colombia in 1993 to that in 2009?
Give a very brief answer. 0.39. What is the ratio of the Aid flow (current US$) in Djibouti in 1993 to that in 2009?
Provide a short and direct response. 0.09. What is the ratio of the Aid flow (current US$) in Nigeria in 1993 to that in 2009?
Offer a very short reply. 0.11. What is the ratio of the Aid flow (current US$) of Belarus in 1993 to that in 2010?
Provide a short and direct response. 0.46. What is the ratio of the Aid flow (current US$) of Colombia in 1993 to that in 2010?
Ensure brevity in your answer.  1.15. What is the ratio of the Aid flow (current US$) in Nigeria in 1993 to that in 2010?
Provide a short and direct response. 0.08. What is the ratio of the Aid flow (current US$) in Belarus in 1993 to that in 2011?
Keep it short and to the point. 1.42. What is the ratio of the Aid flow (current US$) in Colombia in 1993 to that in 2011?
Offer a very short reply. 0.7. What is the ratio of the Aid flow (current US$) of Nigeria in 1993 to that in 2011?
Your response must be concise. 0.07. What is the ratio of the Aid flow (current US$) in Belarus in 1993 to that in 2012?
Offer a terse response. 0.19. What is the ratio of the Aid flow (current US$) in Colombia in 1993 to that in 2012?
Keep it short and to the point. 0.08. What is the ratio of the Aid flow (current US$) of Djibouti in 1993 to that in 2012?
Provide a short and direct response. 1.91. What is the ratio of the Aid flow (current US$) of Nigeria in 1993 to that in 2012?
Ensure brevity in your answer.  0.06. What is the ratio of the Aid flow (current US$) in Colombia in 1993 to that in 2013?
Your response must be concise. 0.27. What is the ratio of the Aid flow (current US$) of Djibouti in 1993 to that in 2013?
Provide a short and direct response. 2.1. What is the ratio of the Aid flow (current US$) of Nigeria in 1993 to that in 2013?
Provide a short and direct response. 0.05. What is the ratio of the Aid flow (current US$) of Belarus in 1994 to that in 2002?
Your response must be concise. 10.11. What is the ratio of the Aid flow (current US$) of Colombia in 1994 to that in 2002?
Provide a short and direct response. 1.31. What is the ratio of the Aid flow (current US$) of Djibouti in 1994 to that in 2002?
Provide a succinct answer. 1. What is the ratio of the Aid flow (current US$) of Nigeria in 1994 to that in 2002?
Offer a terse response. 0.26. What is the ratio of the Aid flow (current US$) of Belarus in 1994 to that in 2009?
Provide a succinct answer. 1.49. What is the ratio of the Aid flow (current US$) of Colombia in 1994 to that in 2009?
Ensure brevity in your answer.  0.53. What is the ratio of the Aid flow (current US$) of Djibouti in 1994 to that in 2009?
Provide a succinct answer. 0.01. What is the ratio of the Aid flow (current US$) in Nigeria in 1994 to that in 2009?
Keep it short and to the point. 0.06. What is the ratio of the Aid flow (current US$) in Belarus in 1994 to that in 2010?
Your answer should be compact. 2.46. What is the ratio of the Aid flow (current US$) in Colombia in 1994 to that in 2010?
Ensure brevity in your answer.  1.56. What is the ratio of the Aid flow (current US$) in Djibouti in 1994 to that in 2010?
Provide a short and direct response. 2. What is the ratio of the Aid flow (current US$) of Nigeria in 1994 to that in 2010?
Provide a short and direct response. 0.04. What is the ratio of the Aid flow (current US$) of Belarus in 1994 to that in 2011?
Your answer should be very brief. 7.58. What is the ratio of the Aid flow (current US$) in Colombia in 1994 to that in 2011?
Provide a succinct answer. 0.94. What is the ratio of the Aid flow (current US$) in Nigeria in 1994 to that in 2011?
Provide a succinct answer. 0.04. What is the ratio of the Aid flow (current US$) of Belarus in 1994 to that in 2012?
Offer a terse response. 1.03. What is the ratio of the Aid flow (current US$) in Colombia in 1994 to that in 2012?
Provide a succinct answer. 0.1. What is the ratio of the Aid flow (current US$) of Djibouti in 1994 to that in 2012?
Your answer should be very brief. 0.18. What is the ratio of the Aid flow (current US$) in Nigeria in 1994 to that in 2012?
Provide a short and direct response. 0.03. What is the ratio of the Aid flow (current US$) in Belarus in 1994 to that in 2013?
Your answer should be compact. 0.89. What is the ratio of the Aid flow (current US$) in Colombia in 1994 to that in 2013?
Keep it short and to the point. 0.37. What is the ratio of the Aid flow (current US$) in Nigeria in 1994 to that in 2013?
Make the answer very short. 0.03. What is the ratio of the Aid flow (current US$) in Belarus in 2002 to that in 2009?
Ensure brevity in your answer.  0.15. What is the ratio of the Aid flow (current US$) in Colombia in 2002 to that in 2009?
Your response must be concise. 0.41. What is the ratio of the Aid flow (current US$) of Djibouti in 2002 to that in 2009?
Offer a terse response. 0.01. What is the ratio of the Aid flow (current US$) in Nigeria in 2002 to that in 2009?
Your answer should be compact. 0.22. What is the ratio of the Aid flow (current US$) of Belarus in 2002 to that in 2010?
Provide a short and direct response. 0.24. What is the ratio of the Aid flow (current US$) in Colombia in 2002 to that in 2010?
Provide a succinct answer. 1.19. What is the ratio of the Aid flow (current US$) of Nigeria in 2002 to that in 2010?
Provide a succinct answer. 0.16. What is the ratio of the Aid flow (current US$) of Colombia in 2002 to that in 2011?
Your response must be concise. 0.72. What is the ratio of the Aid flow (current US$) of Djibouti in 2002 to that in 2011?
Make the answer very short. 1. What is the ratio of the Aid flow (current US$) of Nigeria in 2002 to that in 2011?
Your response must be concise. 0.14. What is the ratio of the Aid flow (current US$) in Belarus in 2002 to that in 2012?
Ensure brevity in your answer.  0.1. What is the ratio of the Aid flow (current US$) in Colombia in 2002 to that in 2012?
Offer a terse response. 0.08. What is the ratio of the Aid flow (current US$) in Djibouti in 2002 to that in 2012?
Keep it short and to the point. 0.18. What is the ratio of the Aid flow (current US$) of Nigeria in 2002 to that in 2012?
Give a very brief answer. 0.13. What is the ratio of the Aid flow (current US$) of Belarus in 2002 to that in 2013?
Your response must be concise. 0.09. What is the ratio of the Aid flow (current US$) of Colombia in 2002 to that in 2013?
Your answer should be very brief. 0.28. What is the ratio of the Aid flow (current US$) in Djibouti in 2002 to that in 2013?
Keep it short and to the point. 0.2. What is the ratio of the Aid flow (current US$) in Nigeria in 2002 to that in 2013?
Your answer should be very brief. 0.11. What is the ratio of the Aid flow (current US$) in Belarus in 2009 to that in 2010?
Keep it short and to the point. 1.65. What is the ratio of the Aid flow (current US$) of Colombia in 2009 to that in 2010?
Keep it short and to the point. 2.94. What is the ratio of the Aid flow (current US$) in Djibouti in 2009 to that in 2010?
Ensure brevity in your answer.  235. What is the ratio of the Aid flow (current US$) of Nigeria in 2009 to that in 2010?
Provide a succinct answer. 0.71. What is the ratio of the Aid flow (current US$) of Belarus in 2009 to that in 2011?
Your answer should be compact. 5.08. What is the ratio of the Aid flow (current US$) of Colombia in 2009 to that in 2011?
Your answer should be very brief. 1.78. What is the ratio of the Aid flow (current US$) of Djibouti in 2009 to that in 2011?
Your answer should be very brief. 117.5. What is the ratio of the Aid flow (current US$) in Nigeria in 2009 to that in 2011?
Make the answer very short. 0.63. What is the ratio of the Aid flow (current US$) in Belarus in 2009 to that in 2012?
Ensure brevity in your answer.  0.69. What is the ratio of the Aid flow (current US$) in Colombia in 2009 to that in 2012?
Ensure brevity in your answer.  0.2. What is the ratio of the Aid flow (current US$) of Djibouti in 2009 to that in 2012?
Your response must be concise. 21.36. What is the ratio of the Aid flow (current US$) of Nigeria in 2009 to that in 2012?
Offer a terse response. 0.6. What is the ratio of the Aid flow (current US$) in Belarus in 2009 to that in 2013?
Your response must be concise. 0.6. What is the ratio of the Aid flow (current US$) of Colombia in 2009 to that in 2013?
Keep it short and to the point. 0.69. What is the ratio of the Aid flow (current US$) of Nigeria in 2009 to that in 2013?
Give a very brief answer. 0.49. What is the ratio of the Aid flow (current US$) in Belarus in 2010 to that in 2011?
Ensure brevity in your answer.  3.08. What is the ratio of the Aid flow (current US$) in Colombia in 2010 to that in 2011?
Your answer should be very brief. 0.61. What is the ratio of the Aid flow (current US$) of Djibouti in 2010 to that in 2011?
Your answer should be very brief. 0.5. What is the ratio of the Aid flow (current US$) of Nigeria in 2010 to that in 2011?
Offer a very short reply. 0.89. What is the ratio of the Aid flow (current US$) in Belarus in 2010 to that in 2012?
Provide a short and direct response. 0.42. What is the ratio of the Aid flow (current US$) of Colombia in 2010 to that in 2012?
Ensure brevity in your answer.  0.07. What is the ratio of the Aid flow (current US$) in Djibouti in 2010 to that in 2012?
Offer a terse response. 0.09. What is the ratio of the Aid flow (current US$) of Nigeria in 2010 to that in 2012?
Provide a short and direct response. 0.85. What is the ratio of the Aid flow (current US$) in Belarus in 2010 to that in 2013?
Give a very brief answer. 0.36. What is the ratio of the Aid flow (current US$) in Colombia in 2010 to that in 2013?
Provide a short and direct response. 0.23. What is the ratio of the Aid flow (current US$) of Djibouti in 2010 to that in 2013?
Your answer should be very brief. 0.1. What is the ratio of the Aid flow (current US$) in Nigeria in 2010 to that in 2013?
Offer a terse response. 0.68. What is the ratio of the Aid flow (current US$) of Belarus in 2011 to that in 2012?
Make the answer very short. 0.14. What is the ratio of the Aid flow (current US$) of Colombia in 2011 to that in 2012?
Provide a succinct answer. 0.11. What is the ratio of the Aid flow (current US$) of Djibouti in 2011 to that in 2012?
Ensure brevity in your answer.  0.18. What is the ratio of the Aid flow (current US$) in Nigeria in 2011 to that in 2012?
Make the answer very short. 0.96. What is the ratio of the Aid flow (current US$) in Belarus in 2011 to that in 2013?
Make the answer very short. 0.12. What is the ratio of the Aid flow (current US$) of Colombia in 2011 to that in 2013?
Make the answer very short. 0.39. What is the ratio of the Aid flow (current US$) in Nigeria in 2011 to that in 2013?
Keep it short and to the point. 0.77. What is the ratio of the Aid flow (current US$) of Belarus in 2012 to that in 2013?
Make the answer very short. 0.86. What is the ratio of the Aid flow (current US$) in Colombia in 2012 to that in 2013?
Your answer should be compact. 3.53. What is the ratio of the Aid flow (current US$) in Nigeria in 2012 to that in 2013?
Give a very brief answer. 0.8. What is the difference between the highest and the second highest Aid flow (current US$) in Belarus?
Provide a succinct answer. 1.10e+05. What is the difference between the highest and the second highest Aid flow (current US$) in Colombia?
Your answer should be compact. 2.85e+07. What is the difference between the highest and the second highest Aid flow (current US$) in Djibouti?
Offer a very short reply. 2.14e+06. What is the difference between the highest and the second highest Aid flow (current US$) in Nigeria?
Your answer should be very brief. 7.62e+07. What is the difference between the highest and the lowest Aid flow (current US$) in Belarus?
Offer a very short reply. 9.30e+05. What is the difference between the highest and the lowest Aid flow (current US$) in Colombia?
Give a very brief answer. 3.71e+07. What is the difference between the highest and the lowest Aid flow (current US$) of Djibouti?
Give a very brief answer. 2.34e+06. What is the difference between the highest and the lowest Aid flow (current US$) of Nigeria?
Your response must be concise. 3.78e+08. 